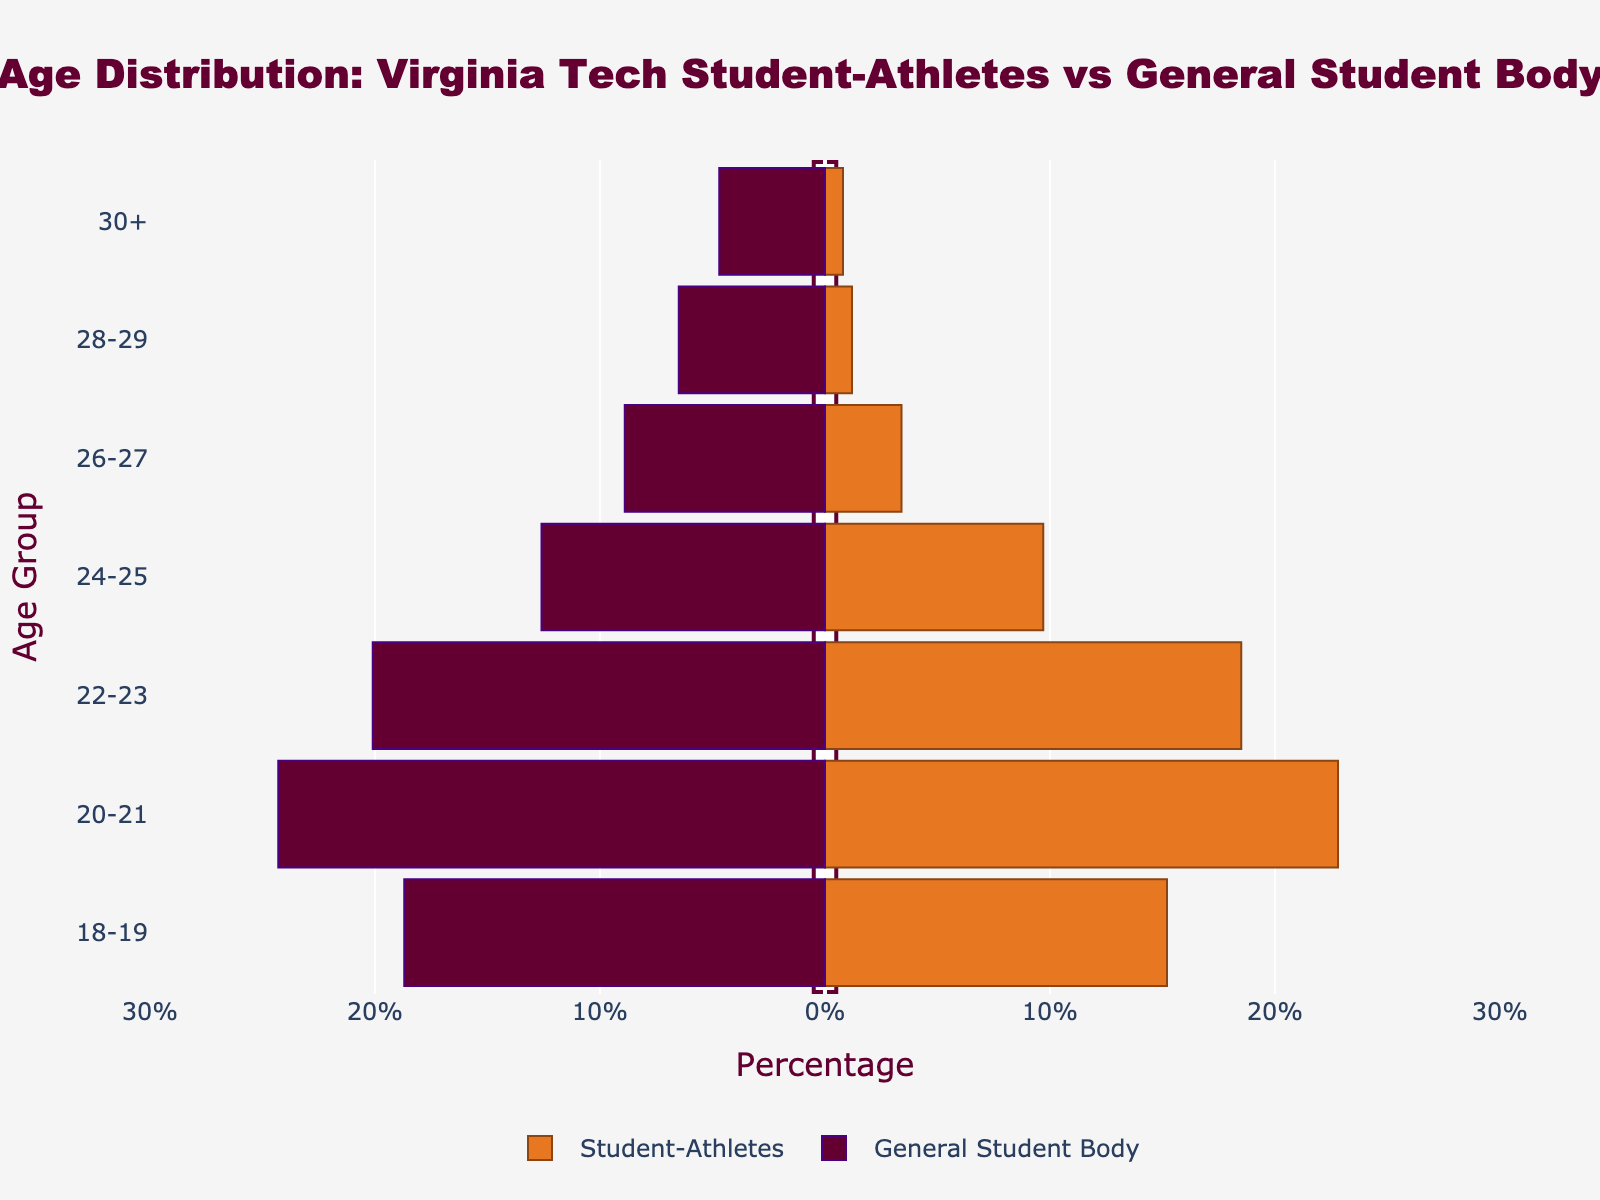What is the title of the figure? The title is found at the top center of the figure and usually summarizes the main topic being visualized.
Answer: Age Distribution: Virginia Tech Student-Athletes vs General Student Body What is the percentage of student-athletes in the 22-23 age group? The percentage for each age group of student-athletes is shown along the x-axis on the positive side of the plot. Locate the 22-23 age group and note the value.
Answer: 18.5% What is the age group with the highest percentage of student-athletes? By examining the positive side of the x-axis, we determine which bar extends the furthest to identify the age group with the highest percentage.
Answer: 20-21 Which age group's general student body percentage is closest to 10%? On the negative side of the x-axis, find the bar that is closest to the -10% mark to determine the relevant age group.
Answer: 24-25 What is the total percentage of both groups for the 18-19 age group? Sum the absolute values of the percentages for student-athletes and the general student body in the 18-19 age group from both sides of the x-axis.
Answer: 33.9%, calculated as 15.2% (students) + 18.7% (general) Which group has a higher percentage in the 24-25 age group, and by how much? Compare the values for both student-athletes and the general student body in the 24-25 age group. Subtract the smaller value from the larger one.
Answer: General student body by 2.9%, calculated as 12.6% - 9.7% Is there any age group where the percentage of student-athletes is greater than that of the general student body? Compare each age group's percentages between student-athletes and the general student body. Identify if there's an age group where the student-athletes' bar is larger.
Answer: No In which age group is the percentage difference between the two groups the largest, and what is that difference? Calculate the absolute differences for each age group by subtracting the student-athletes' percentage from the general student body's percentage and identify the largest difference.
Answer: 26-27, with a difference of 5.5%, calculated as 8.9% - 3.4% Which age group has the smallest percentage for student-athletes and what is that value? Observe the positive side of the plot (student-athletes) and identify the smallest bar to find the relevant age group and percentage.
Answer: 30+, with 0.8% 